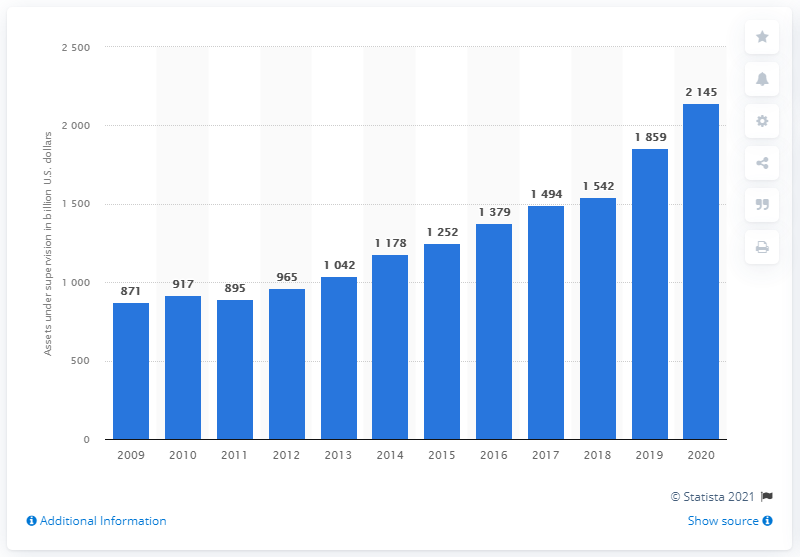Point out several critical features in this image. In 2020, Goldman Sachs supervised a total of 2,145 U.S. dollars in assets. 